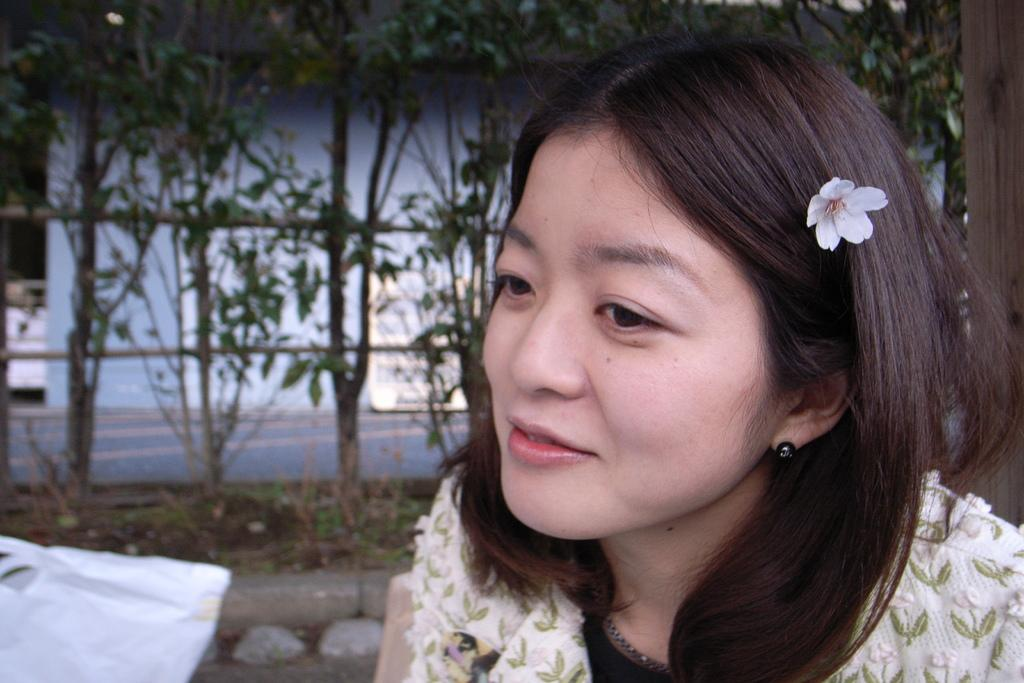Who is the main subject in the image? There is a woman in the image. What is a noticeable detail about the woman's appearance? The woman has a flower in her hair. What can be seen in the background of the image? There are plants in the background of the image. What type of mitten is the woman wearing in the image? There is no mitten present in the image; the woman has a flower in her hair. 